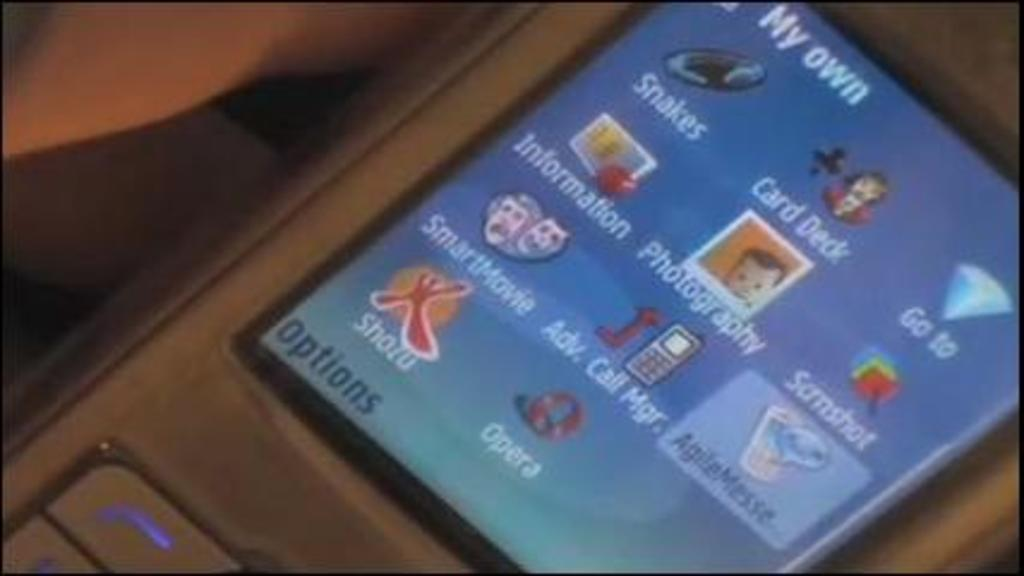<image>
Provide a brief description of the given image. An old phone with My Own written at the top is being held in a hand 